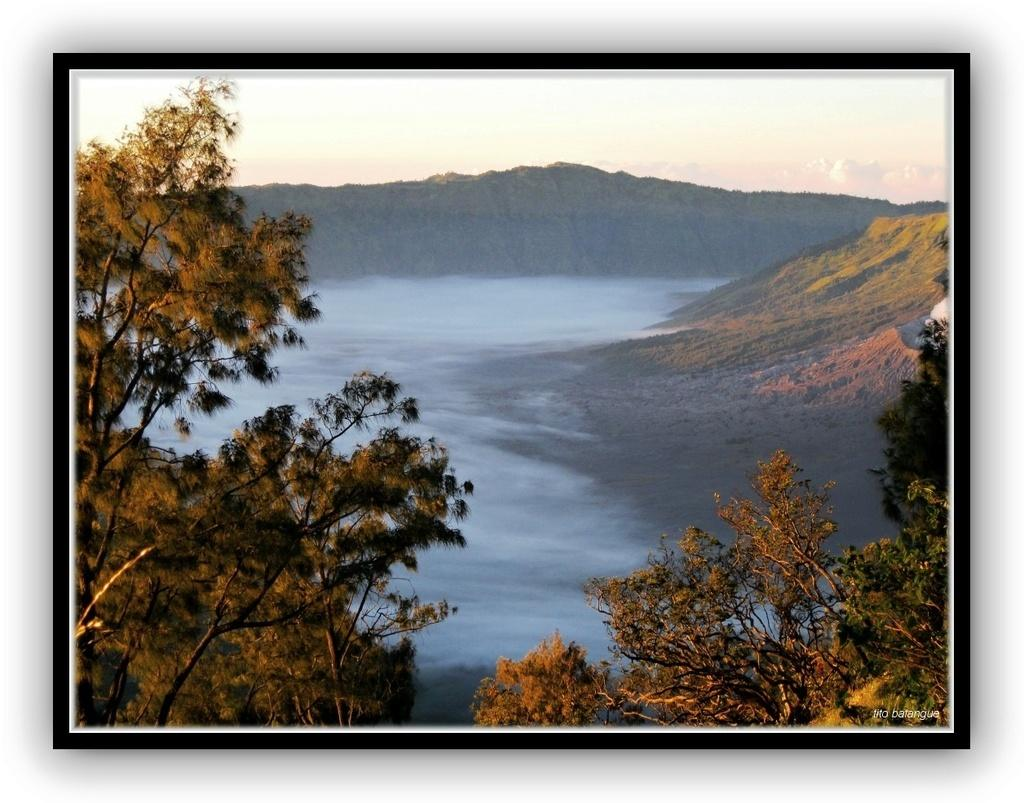What is the main feature in the center of the image? There is a river in the center of the image. What type of vegetation can be seen at the bottom and at the left side of the image? There are trees at the bottom and at the left side of the image. What type of geographical feature is present at the top and at the right side of the image? There are hills at the top and at the right side of the image. What type of clover can be seen growing near the river in the image? There is no clover present in the image; only trees and hills are visible. 